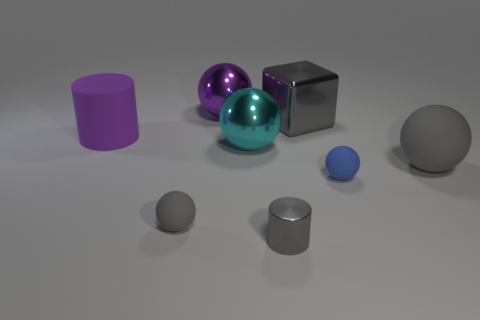What kind of lighting does the scene have? The scene is lit with a soft, diffused overhead light, which casts gentle shadows beneath the objects and contributes to the calm mood of the composition. 